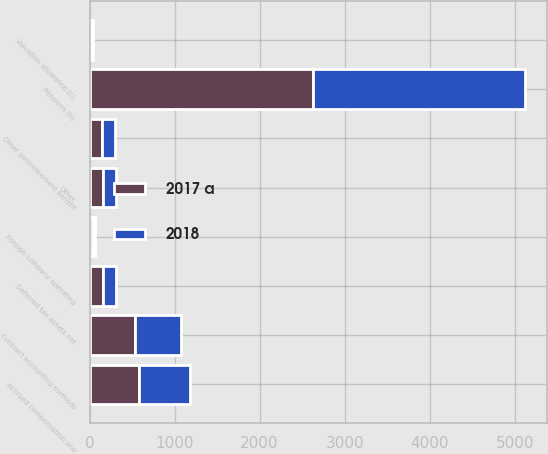Convert chart to OTSL. <chart><loc_0><loc_0><loc_500><loc_500><stacked_bar_chart><ecel><fcel>Accrued compensation and<fcel>Pensions (b)<fcel>Other postretirement benefit<fcel>Contract accounting methods<fcel>Foreign company operating<fcel>Other<fcel>Valuation allowance (c)<fcel>Deferred tax assets net<nl><fcel>2017 a<fcel>584<fcel>2623<fcel>148<fcel>539<fcel>38<fcel>160<fcel>20<fcel>157<nl><fcel>2018<fcel>595<fcel>2495<fcel>153<fcel>531<fcel>27<fcel>154<fcel>20<fcel>157<nl></chart> 